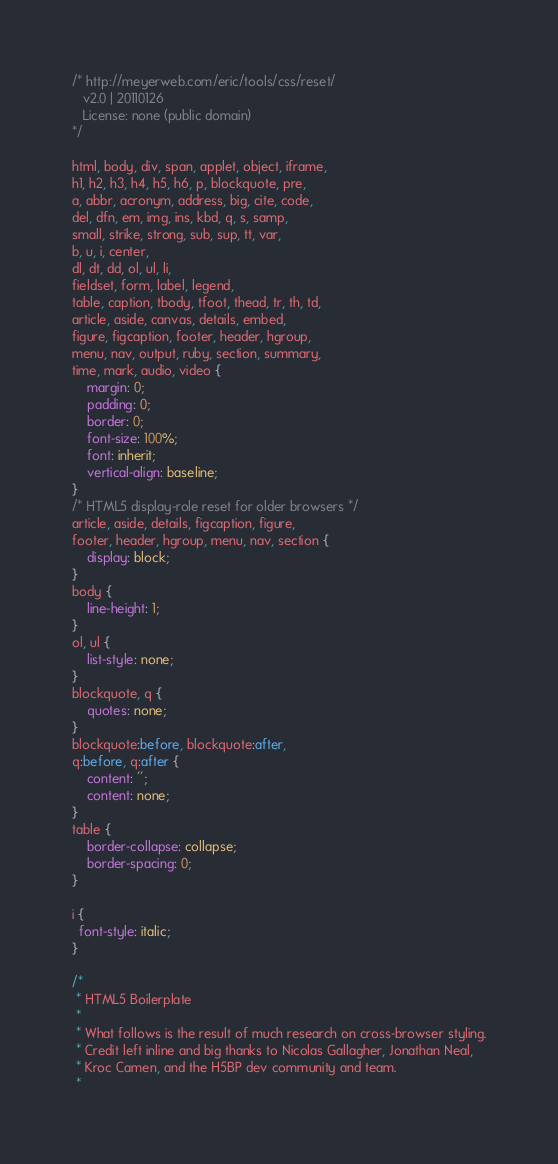Convert code to text. <code><loc_0><loc_0><loc_500><loc_500><_CSS_>/* http://meyerweb.com/eric/tools/css/reset/ 
   v2.0 | 20110126
   License: none (public domain)
*/

html, body, div, span, applet, object, iframe,
h1, h2, h3, h4, h5, h6, p, blockquote, pre,
a, abbr, acronym, address, big, cite, code,
del, dfn, em, img, ins, kbd, q, s, samp,
small, strike, strong, sub, sup, tt, var,
b, u, i, center,
dl, dt, dd, ol, ul, li,
fieldset, form, label, legend,
table, caption, tbody, tfoot, thead, tr, th, td,
article, aside, canvas, details, embed, 
figure, figcaption, footer, header, hgroup, 
menu, nav, output, ruby, section, summary,
time, mark, audio, video {
	margin: 0;
	padding: 0;
	border: 0;
	font-size: 100%;
	font: inherit;
	vertical-align: baseline;
}
/* HTML5 display-role reset for older browsers */
article, aside, details, figcaption, figure, 
footer, header, hgroup, menu, nav, section {
	display: block;
}
body {
	line-height: 1;
}
ol, ul {
	list-style: none;
}
blockquote, q {
	quotes: none;
}
blockquote:before, blockquote:after,
q:before, q:after {
	content: '';
	content: none;
}
table {
	border-collapse: collapse;
	border-spacing: 0;
}

i {
  font-style: italic;
}

/*
 * HTML5 Boilerplate
 *
 * What follows is the result of much research on cross-browser styling.
 * Credit left inline and big thanks to Nicolas Gallagher, Jonathan Neal,
 * Kroc Camen, and the H5BP dev community and team.
 *</code> 